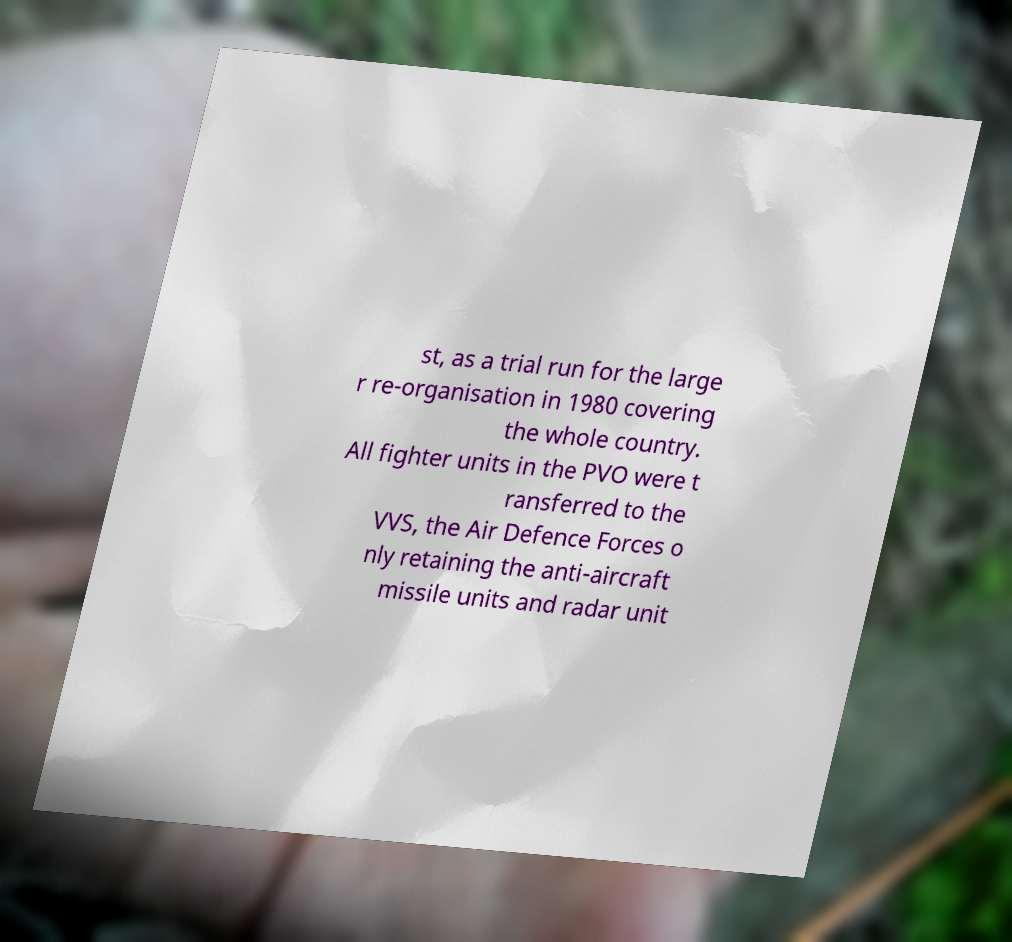For documentation purposes, I need the text within this image transcribed. Could you provide that? st, as a trial run for the large r re-organisation in 1980 covering the whole country. All fighter units in the PVO were t ransferred to the VVS, the Air Defence Forces o nly retaining the anti-aircraft missile units and radar unit 